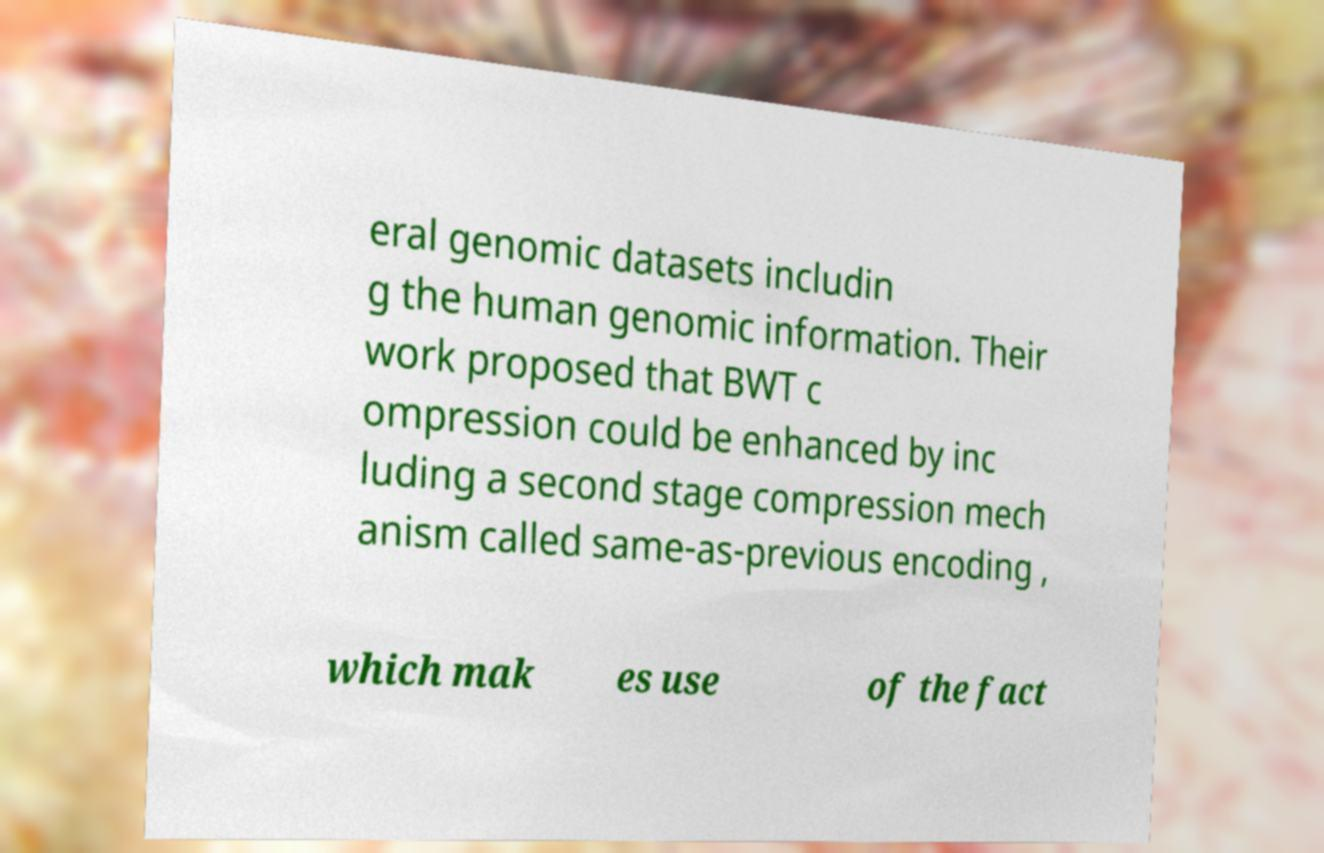For documentation purposes, I need the text within this image transcribed. Could you provide that? eral genomic datasets includin g the human genomic information. Their work proposed that BWT c ompression could be enhanced by inc luding a second stage compression mech anism called same-as-previous encoding , which mak es use of the fact 